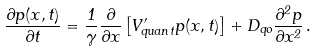<formula> <loc_0><loc_0><loc_500><loc_500>\frac { \partial p ( x , t ) } { \partial t } = \frac { 1 } { \gamma } \frac { \partial } { \partial x } \left [ V _ { q u a n t } ^ { \prime } p ( x , t ) \right ] + D _ { q o } \frac { \partial ^ { 2 } p } { \partial x ^ { 2 } } \, .</formula> 